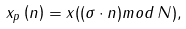Convert formula to latex. <formula><loc_0><loc_0><loc_500><loc_500>x _ { p } \left ( n \right ) = x ( ( \sigma \cdot n ) m o d \, N ) ,</formula> 